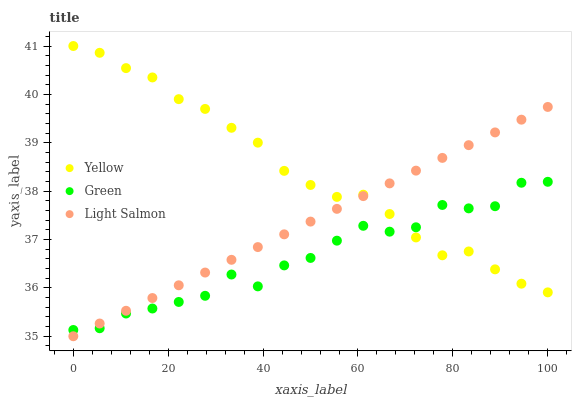Does Green have the minimum area under the curve?
Answer yes or no. Yes. Does Yellow have the maximum area under the curve?
Answer yes or no. Yes. Does Yellow have the minimum area under the curve?
Answer yes or no. No. Does Green have the maximum area under the curve?
Answer yes or no. No. Is Light Salmon the smoothest?
Answer yes or no. Yes. Is Green the roughest?
Answer yes or no. Yes. Is Yellow the smoothest?
Answer yes or no. No. Is Yellow the roughest?
Answer yes or no. No. Does Light Salmon have the lowest value?
Answer yes or no. Yes. Does Green have the lowest value?
Answer yes or no. No. Does Yellow have the highest value?
Answer yes or no. Yes. Does Green have the highest value?
Answer yes or no. No. Does Light Salmon intersect Green?
Answer yes or no. Yes. Is Light Salmon less than Green?
Answer yes or no. No. Is Light Salmon greater than Green?
Answer yes or no. No. 